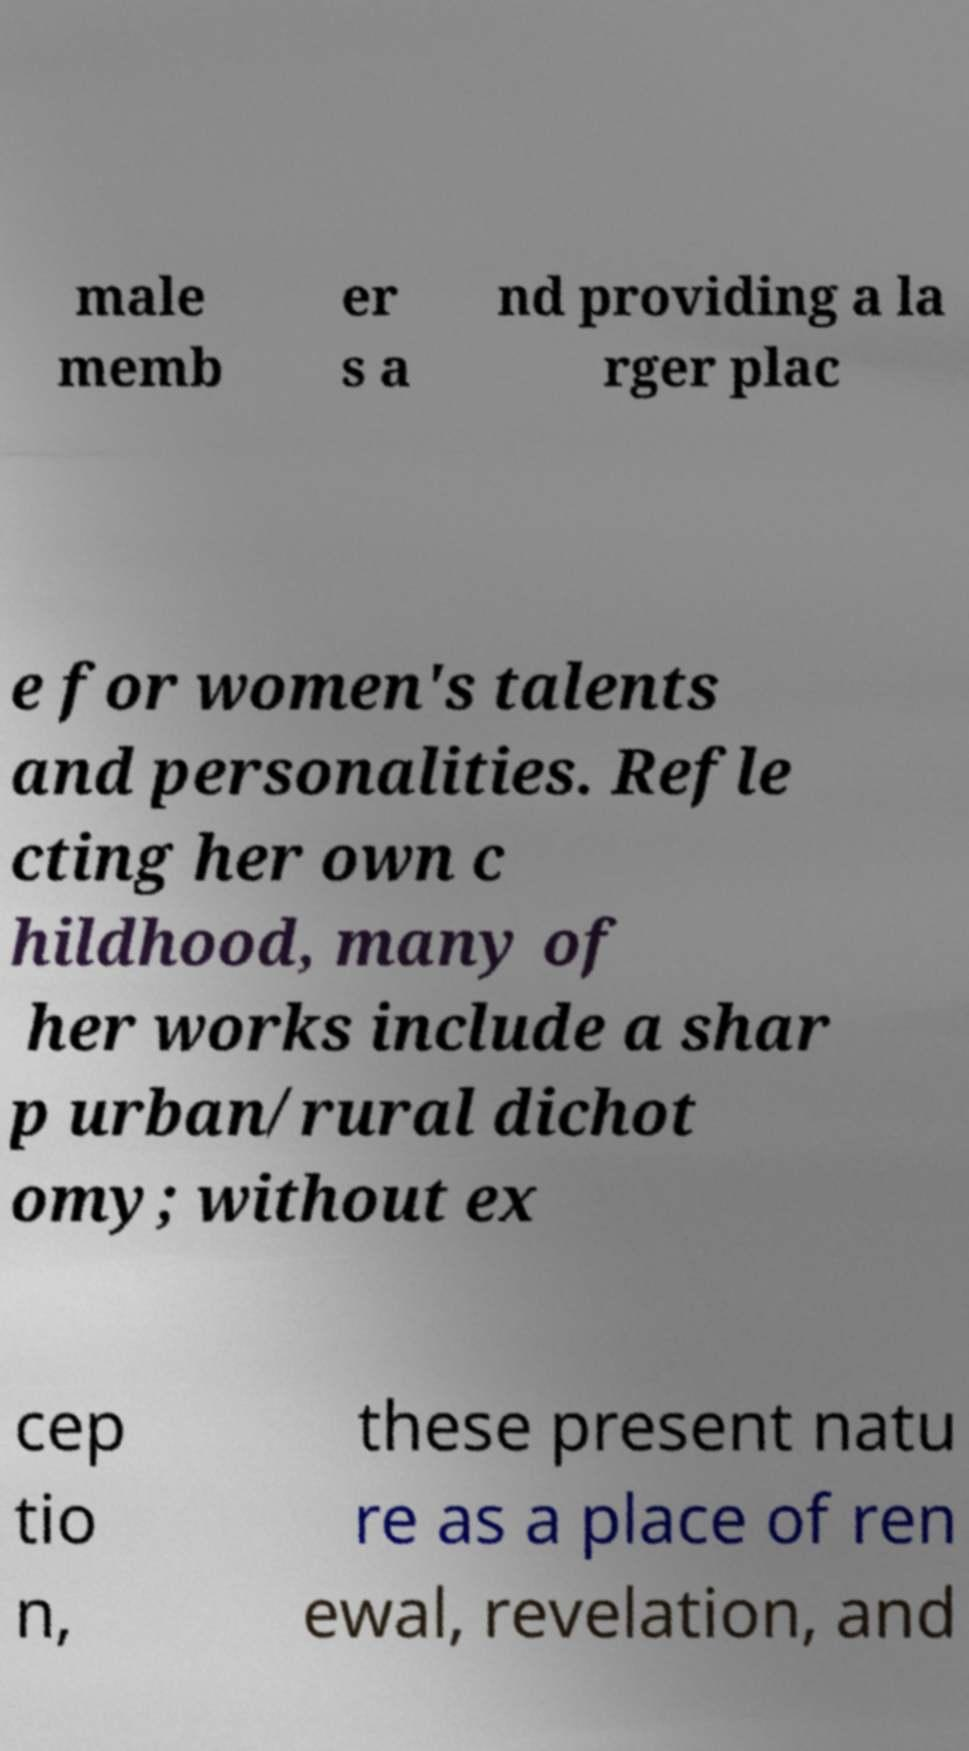For documentation purposes, I need the text within this image transcribed. Could you provide that? male memb er s a nd providing a la rger plac e for women's talents and personalities. Refle cting her own c hildhood, many of her works include a shar p urban/rural dichot omy; without ex cep tio n, these present natu re as a place of ren ewal, revelation, and 